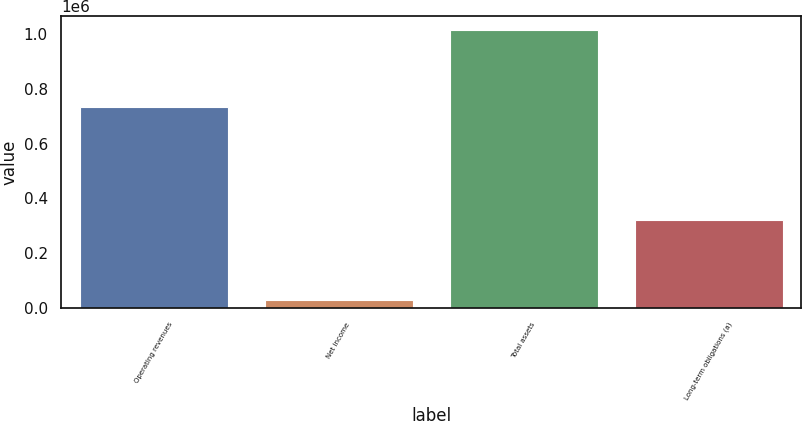Convert chart. <chart><loc_0><loc_0><loc_500><loc_500><bar_chart><fcel>Operating revenues<fcel>Net income<fcel>Total assets<fcel>Long-term obligations (a)<nl><fcel>735192<fcel>31030<fcel>1.01492e+06<fcel>323280<nl></chart> 